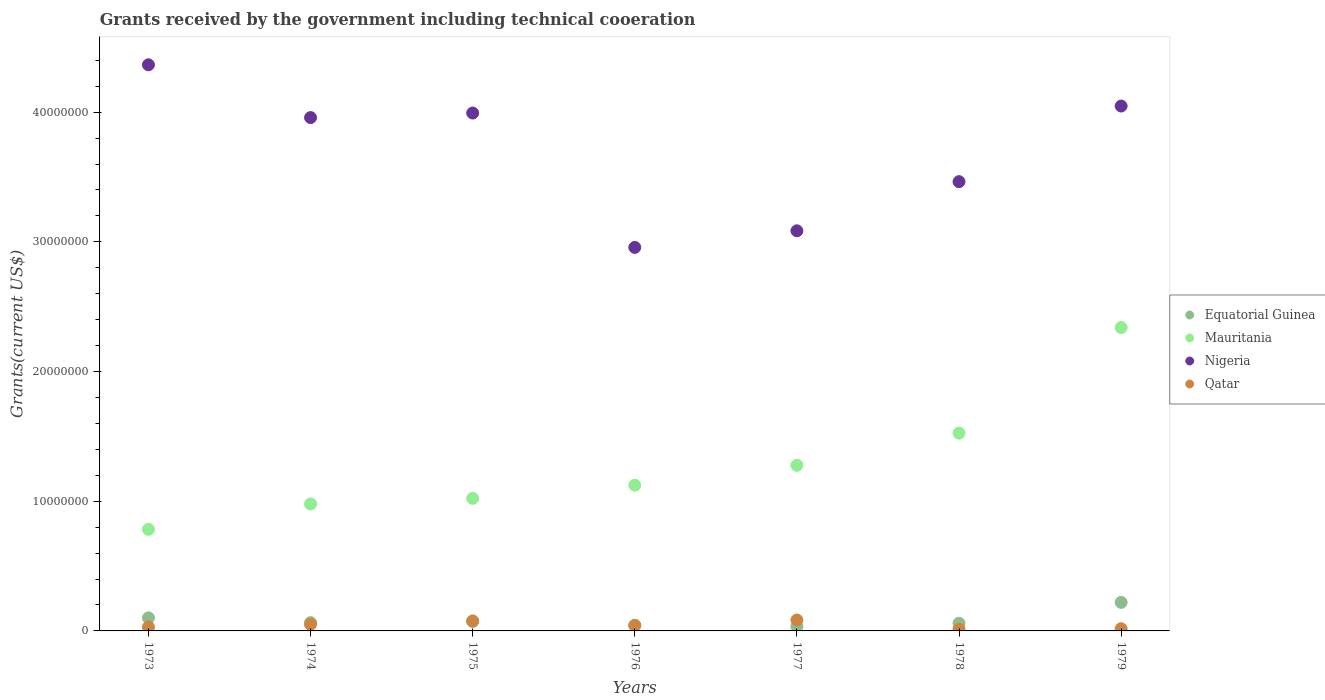How many different coloured dotlines are there?
Ensure brevity in your answer.  4. What is the total grants received by the government in Qatar in 1979?
Your response must be concise. 1.70e+05. Across all years, what is the maximum total grants received by the government in Nigeria?
Keep it short and to the point. 4.36e+07. Across all years, what is the minimum total grants received by the government in Mauritania?
Ensure brevity in your answer.  7.83e+06. In which year was the total grants received by the government in Nigeria maximum?
Your answer should be compact. 1973. What is the total total grants received by the government in Nigeria in the graph?
Make the answer very short. 2.59e+08. What is the difference between the total grants received by the government in Mauritania in 1976 and that in 1979?
Your answer should be compact. -1.22e+07. What is the difference between the total grants received by the government in Qatar in 1979 and the total grants received by the government in Nigeria in 1975?
Your answer should be very brief. -3.98e+07. What is the average total grants received by the government in Equatorial Guinea per year?
Offer a terse response. 8.47e+05. What is the ratio of the total grants received by the government in Equatorial Guinea in 1973 to that in 1979?
Keep it short and to the point. 0.46. Is the difference between the total grants received by the government in Equatorial Guinea in 1974 and 1978 greater than the difference between the total grants received by the government in Qatar in 1974 and 1978?
Your answer should be very brief. No. What is the difference between the highest and the second highest total grants received by the government in Mauritania?
Provide a short and direct response. 8.14e+06. What is the difference between the highest and the lowest total grants received by the government in Qatar?
Offer a very short reply. 7.00e+05. In how many years, is the total grants received by the government in Equatorial Guinea greater than the average total grants received by the government in Equatorial Guinea taken over all years?
Provide a succinct answer. 2. Does the total grants received by the government in Equatorial Guinea monotonically increase over the years?
Ensure brevity in your answer.  No. Is the total grants received by the government in Mauritania strictly greater than the total grants received by the government in Qatar over the years?
Offer a terse response. Yes. Is the total grants received by the government in Nigeria strictly less than the total grants received by the government in Qatar over the years?
Offer a terse response. No. Are the values on the major ticks of Y-axis written in scientific E-notation?
Your response must be concise. No. Where does the legend appear in the graph?
Make the answer very short. Center right. How many legend labels are there?
Provide a succinct answer. 4. What is the title of the graph?
Your answer should be compact. Grants received by the government including technical cooeration. Does "Virgin Islands" appear as one of the legend labels in the graph?
Provide a short and direct response. No. What is the label or title of the Y-axis?
Offer a terse response. Grants(current US$). What is the Grants(current US$) in Equatorial Guinea in 1973?
Provide a short and direct response. 1.01e+06. What is the Grants(current US$) of Mauritania in 1973?
Give a very brief answer. 7.83e+06. What is the Grants(current US$) of Nigeria in 1973?
Make the answer very short. 4.36e+07. What is the Grants(current US$) in Qatar in 1973?
Your response must be concise. 3.00e+05. What is the Grants(current US$) in Equatorial Guinea in 1974?
Offer a terse response. 6.40e+05. What is the Grants(current US$) of Mauritania in 1974?
Provide a succinct answer. 9.79e+06. What is the Grants(current US$) of Nigeria in 1974?
Your response must be concise. 3.96e+07. What is the Grants(current US$) in Qatar in 1974?
Provide a succinct answer. 5.10e+05. What is the Grants(current US$) of Equatorial Guinea in 1975?
Offer a very short reply. 7.30e+05. What is the Grants(current US$) in Mauritania in 1975?
Your response must be concise. 1.02e+07. What is the Grants(current US$) in Nigeria in 1975?
Provide a succinct answer. 3.99e+07. What is the Grants(current US$) of Qatar in 1975?
Ensure brevity in your answer.  7.70e+05. What is the Grants(current US$) of Equatorial Guinea in 1976?
Your answer should be very brief. 4.20e+05. What is the Grants(current US$) of Mauritania in 1976?
Your answer should be compact. 1.12e+07. What is the Grants(current US$) in Nigeria in 1976?
Provide a succinct answer. 2.96e+07. What is the Grants(current US$) of Mauritania in 1977?
Provide a succinct answer. 1.28e+07. What is the Grants(current US$) in Nigeria in 1977?
Provide a short and direct response. 3.08e+07. What is the Grants(current US$) in Qatar in 1977?
Keep it short and to the point. 8.40e+05. What is the Grants(current US$) in Equatorial Guinea in 1978?
Provide a succinct answer. 5.90e+05. What is the Grants(current US$) in Mauritania in 1978?
Provide a succinct answer. 1.52e+07. What is the Grants(current US$) of Nigeria in 1978?
Your answer should be very brief. 3.46e+07. What is the Grants(current US$) in Equatorial Guinea in 1979?
Keep it short and to the point. 2.20e+06. What is the Grants(current US$) of Mauritania in 1979?
Offer a very short reply. 2.34e+07. What is the Grants(current US$) of Nigeria in 1979?
Offer a very short reply. 4.05e+07. What is the Grants(current US$) of Qatar in 1979?
Your answer should be compact. 1.70e+05. Across all years, what is the maximum Grants(current US$) in Equatorial Guinea?
Offer a terse response. 2.20e+06. Across all years, what is the maximum Grants(current US$) in Mauritania?
Keep it short and to the point. 2.34e+07. Across all years, what is the maximum Grants(current US$) in Nigeria?
Offer a very short reply. 4.36e+07. Across all years, what is the maximum Grants(current US$) in Qatar?
Your response must be concise. 8.40e+05. Across all years, what is the minimum Grants(current US$) in Equatorial Guinea?
Your response must be concise. 3.40e+05. Across all years, what is the minimum Grants(current US$) of Mauritania?
Keep it short and to the point. 7.83e+06. Across all years, what is the minimum Grants(current US$) in Nigeria?
Ensure brevity in your answer.  2.96e+07. What is the total Grants(current US$) in Equatorial Guinea in the graph?
Make the answer very short. 5.93e+06. What is the total Grants(current US$) of Mauritania in the graph?
Give a very brief answer. 9.05e+07. What is the total Grants(current US$) in Nigeria in the graph?
Give a very brief answer. 2.59e+08. What is the total Grants(current US$) in Qatar in the graph?
Make the answer very short. 3.16e+06. What is the difference between the Grants(current US$) in Mauritania in 1973 and that in 1974?
Offer a very short reply. -1.96e+06. What is the difference between the Grants(current US$) of Nigeria in 1973 and that in 1974?
Provide a succinct answer. 4.07e+06. What is the difference between the Grants(current US$) in Qatar in 1973 and that in 1974?
Ensure brevity in your answer.  -2.10e+05. What is the difference between the Grants(current US$) in Mauritania in 1973 and that in 1975?
Ensure brevity in your answer.  -2.39e+06. What is the difference between the Grants(current US$) in Nigeria in 1973 and that in 1975?
Offer a terse response. 3.72e+06. What is the difference between the Grants(current US$) of Qatar in 1973 and that in 1975?
Keep it short and to the point. -4.70e+05. What is the difference between the Grants(current US$) of Equatorial Guinea in 1973 and that in 1976?
Your answer should be compact. 5.90e+05. What is the difference between the Grants(current US$) of Mauritania in 1973 and that in 1976?
Your response must be concise. -3.41e+06. What is the difference between the Grants(current US$) of Nigeria in 1973 and that in 1976?
Your answer should be very brief. 1.41e+07. What is the difference between the Grants(current US$) of Equatorial Guinea in 1973 and that in 1977?
Make the answer very short. 6.70e+05. What is the difference between the Grants(current US$) in Mauritania in 1973 and that in 1977?
Your response must be concise. -4.94e+06. What is the difference between the Grants(current US$) of Nigeria in 1973 and that in 1977?
Provide a succinct answer. 1.28e+07. What is the difference between the Grants(current US$) in Qatar in 1973 and that in 1977?
Provide a succinct answer. -5.40e+05. What is the difference between the Grants(current US$) of Equatorial Guinea in 1973 and that in 1978?
Provide a succinct answer. 4.20e+05. What is the difference between the Grants(current US$) in Mauritania in 1973 and that in 1978?
Keep it short and to the point. -7.42e+06. What is the difference between the Grants(current US$) of Nigeria in 1973 and that in 1978?
Provide a short and direct response. 9.01e+06. What is the difference between the Grants(current US$) in Equatorial Guinea in 1973 and that in 1979?
Provide a succinct answer. -1.19e+06. What is the difference between the Grants(current US$) of Mauritania in 1973 and that in 1979?
Give a very brief answer. -1.56e+07. What is the difference between the Grants(current US$) in Nigeria in 1973 and that in 1979?
Offer a terse response. 3.18e+06. What is the difference between the Grants(current US$) of Mauritania in 1974 and that in 1975?
Provide a succinct answer. -4.30e+05. What is the difference between the Grants(current US$) in Nigeria in 1974 and that in 1975?
Your answer should be very brief. -3.50e+05. What is the difference between the Grants(current US$) in Equatorial Guinea in 1974 and that in 1976?
Keep it short and to the point. 2.20e+05. What is the difference between the Grants(current US$) of Mauritania in 1974 and that in 1976?
Keep it short and to the point. -1.45e+06. What is the difference between the Grants(current US$) in Nigeria in 1974 and that in 1976?
Keep it short and to the point. 1.00e+07. What is the difference between the Grants(current US$) in Qatar in 1974 and that in 1976?
Provide a succinct answer. 8.00e+04. What is the difference between the Grants(current US$) of Equatorial Guinea in 1974 and that in 1977?
Offer a terse response. 3.00e+05. What is the difference between the Grants(current US$) of Mauritania in 1974 and that in 1977?
Offer a terse response. -2.98e+06. What is the difference between the Grants(current US$) of Nigeria in 1974 and that in 1977?
Your answer should be very brief. 8.73e+06. What is the difference between the Grants(current US$) of Qatar in 1974 and that in 1977?
Your response must be concise. -3.30e+05. What is the difference between the Grants(current US$) in Equatorial Guinea in 1974 and that in 1978?
Ensure brevity in your answer.  5.00e+04. What is the difference between the Grants(current US$) in Mauritania in 1974 and that in 1978?
Your answer should be very brief. -5.46e+06. What is the difference between the Grants(current US$) in Nigeria in 1974 and that in 1978?
Your answer should be very brief. 4.94e+06. What is the difference between the Grants(current US$) of Equatorial Guinea in 1974 and that in 1979?
Ensure brevity in your answer.  -1.56e+06. What is the difference between the Grants(current US$) of Mauritania in 1974 and that in 1979?
Offer a terse response. -1.36e+07. What is the difference between the Grants(current US$) of Nigeria in 1974 and that in 1979?
Offer a very short reply. -8.90e+05. What is the difference between the Grants(current US$) in Qatar in 1974 and that in 1979?
Make the answer very short. 3.40e+05. What is the difference between the Grants(current US$) in Mauritania in 1975 and that in 1976?
Provide a short and direct response. -1.02e+06. What is the difference between the Grants(current US$) in Nigeria in 1975 and that in 1976?
Provide a succinct answer. 1.04e+07. What is the difference between the Grants(current US$) of Qatar in 1975 and that in 1976?
Provide a succinct answer. 3.40e+05. What is the difference between the Grants(current US$) in Mauritania in 1975 and that in 1977?
Make the answer very short. -2.55e+06. What is the difference between the Grants(current US$) in Nigeria in 1975 and that in 1977?
Make the answer very short. 9.08e+06. What is the difference between the Grants(current US$) of Mauritania in 1975 and that in 1978?
Your answer should be compact. -5.03e+06. What is the difference between the Grants(current US$) of Nigeria in 1975 and that in 1978?
Offer a very short reply. 5.29e+06. What is the difference between the Grants(current US$) in Qatar in 1975 and that in 1978?
Ensure brevity in your answer.  6.30e+05. What is the difference between the Grants(current US$) of Equatorial Guinea in 1975 and that in 1979?
Keep it short and to the point. -1.47e+06. What is the difference between the Grants(current US$) of Mauritania in 1975 and that in 1979?
Keep it short and to the point. -1.32e+07. What is the difference between the Grants(current US$) in Nigeria in 1975 and that in 1979?
Provide a short and direct response. -5.40e+05. What is the difference between the Grants(current US$) of Qatar in 1975 and that in 1979?
Your answer should be compact. 6.00e+05. What is the difference between the Grants(current US$) of Mauritania in 1976 and that in 1977?
Your answer should be very brief. -1.53e+06. What is the difference between the Grants(current US$) in Nigeria in 1976 and that in 1977?
Ensure brevity in your answer.  -1.28e+06. What is the difference between the Grants(current US$) in Qatar in 1976 and that in 1977?
Offer a terse response. -4.10e+05. What is the difference between the Grants(current US$) in Equatorial Guinea in 1976 and that in 1978?
Give a very brief answer. -1.70e+05. What is the difference between the Grants(current US$) in Mauritania in 1976 and that in 1978?
Offer a terse response. -4.01e+06. What is the difference between the Grants(current US$) in Nigeria in 1976 and that in 1978?
Give a very brief answer. -5.07e+06. What is the difference between the Grants(current US$) of Qatar in 1976 and that in 1978?
Keep it short and to the point. 2.90e+05. What is the difference between the Grants(current US$) of Equatorial Guinea in 1976 and that in 1979?
Offer a very short reply. -1.78e+06. What is the difference between the Grants(current US$) of Mauritania in 1976 and that in 1979?
Your answer should be compact. -1.22e+07. What is the difference between the Grants(current US$) in Nigeria in 1976 and that in 1979?
Your response must be concise. -1.09e+07. What is the difference between the Grants(current US$) of Qatar in 1976 and that in 1979?
Keep it short and to the point. 2.60e+05. What is the difference between the Grants(current US$) of Mauritania in 1977 and that in 1978?
Ensure brevity in your answer.  -2.48e+06. What is the difference between the Grants(current US$) in Nigeria in 1977 and that in 1978?
Give a very brief answer. -3.79e+06. What is the difference between the Grants(current US$) of Qatar in 1977 and that in 1978?
Your response must be concise. 7.00e+05. What is the difference between the Grants(current US$) of Equatorial Guinea in 1977 and that in 1979?
Your answer should be very brief. -1.86e+06. What is the difference between the Grants(current US$) of Mauritania in 1977 and that in 1979?
Make the answer very short. -1.06e+07. What is the difference between the Grants(current US$) in Nigeria in 1977 and that in 1979?
Provide a succinct answer. -9.62e+06. What is the difference between the Grants(current US$) in Qatar in 1977 and that in 1979?
Your answer should be compact. 6.70e+05. What is the difference between the Grants(current US$) of Equatorial Guinea in 1978 and that in 1979?
Your response must be concise. -1.61e+06. What is the difference between the Grants(current US$) in Mauritania in 1978 and that in 1979?
Make the answer very short. -8.14e+06. What is the difference between the Grants(current US$) of Nigeria in 1978 and that in 1979?
Ensure brevity in your answer.  -5.83e+06. What is the difference between the Grants(current US$) in Equatorial Guinea in 1973 and the Grants(current US$) in Mauritania in 1974?
Provide a succinct answer. -8.78e+06. What is the difference between the Grants(current US$) of Equatorial Guinea in 1973 and the Grants(current US$) of Nigeria in 1974?
Offer a terse response. -3.86e+07. What is the difference between the Grants(current US$) in Mauritania in 1973 and the Grants(current US$) in Nigeria in 1974?
Ensure brevity in your answer.  -3.18e+07. What is the difference between the Grants(current US$) of Mauritania in 1973 and the Grants(current US$) of Qatar in 1974?
Offer a very short reply. 7.32e+06. What is the difference between the Grants(current US$) in Nigeria in 1973 and the Grants(current US$) in Qatar in 1974?
Your answer should be compact. 4.31e+07. What is the difference between the Grants(current US$) in Equatorial Guinea in 1973 and the Grants(current US$) in Mauritania in 1975?
Your answer should be compact. -9.21e+06. What is the difference between the Grants(current US$) of Equatorial Guinea in 1973 and the Grants(current US$) of Nigeria in 1975?
Ensure brevity in your answer.  -3.89e+07. What is the difference between the Grants(current US$) in Mauritania in 1973 and the Grants(current US$) in Nigeria in 1975?
Provide a succinct answer. -3.21e+07. What is the difference between the Grants(current US$) of Mauritania in 1973 and the Grants(current US$) of Qatar in 1975?
Offer a terse response. 7.06e+06. What is the difference between the Grants(current US$) in Nigeria in 1973 and the Grants(current US$) in Qatar in 1975?
Ensure brevity in your answer.  4.29e+07. What is the difference between the Grants(current US$) of Equatorial Guinea in 1973 and the Grants(current US$) of Mauritania in 1976?
Keep it short and to the point. -1.02e+07. What is the difference between the Grants(current US$) in Equatorial Guinea in 1973 and the Grants(current US$) in Nigeria in 1976?
Make the answer very short. -2.86e+07. What is the difference between the Grants(current US$) in Equatorial Guinea in 1973 and the Grants(current US$) in Qatar in 1976?
Keep it short and to the point. 5.80e+05. What is the difference between the Grants(current US$) in Mauritania in 1973 and the Grants(current US$) in Nigeria in 1976?
Offer a terse response. -2.17e+07. What is the difference between the Grants(current US$) in Mauritania in 1973 and the Grants(current US$) in Qatar in 1976?
Provide a short and direct response. 7.40e+06. What is the difference between the Grants(current US$) in Nigeria in 1973 and the Grants(current US$) in Qatar in 1976?
Make the answer very short. 4.32e+07. What is the difference between the Grants(current US$) in Equatorial Guinea in 1973 and the Grants(current US$) in Mauritania in 1977?
Keep it short and to the point. -1.18e+07. What is the difference between the Grants(current US$) of Equatorial Guinea in 1973 and the Grants(current US$) of Nigeria in 1977?
Your answer should be very brief. -2.98e+07. What is the difference between the Grants(current US$) of Equatorial Guinea in 1973 and the Grants(current US$) of Qatar in 1977?
Offer a very short reply. 1.70e+05. What is the difference between the Grants(current US$) in Mauritania in 1973 and the Grants(current US$) in Nigeria in 1977?
Offer a very short reply. -2.30e+07. What is the difference between the Grants(current US$) in Mauritania in 1973 and the Grants(current US$) in Qatar in 1977?
Ensure brevity in your answer.  6.99e+06. What is the difference between the Grants(current US$) in Nigeria in 1973 and the Grants(current US$) in Qatar in 1977?
Offer a terse response. 4.28e+07. What is the difference between the Grants(current US$) of Equatorial Guinea in 1973 and the Grants(current US$) of Mauritania in 1978?
Offer a very short reply. -1.42e+07. What is the difference between the Grants(current US$) in Equatorial Guinea in 1973 and the Grants(current US$) in Nigeria in 1978?
Offer a terse response. -3.36e+07. What is the difference between the Grants(current US$) of Equatorial Guinea in 1973 and the Grants(current US$) of Qatar in 1978?
Make the answer very short. 8.70e+05. What is the difference between the Grants(current US$) in Mauritania in 1973 and the Grants(current US$) in Nigeria in 1978?
Offer a very short reply. -2.68e+07. What is the difference between the Grants(current US$) of Mauritania in 1973 and the Grants(current US$) of Qatar in 1978?
Your response must be concise. 7.69e+06. What is the difference between the Grants(current US$) of Nigeria in 1973 and the Grants(current US$) of Qatar in 1978?
Offer a terse response. 4.35e+07. What is the difference between the Grants(current US$) in Equatorial Guinea in 1973 and the Grants(current US$) in Mauritania in 1979?
Your answer should be compact. -2.24e+07. What is the difference between the Grants(current US$) in Equatorial Guinea in 1973 and the Grants(current US$) in Nigeria in 1979?
Make the answer very short. -3.95e+07. What is the difference between the Grants(current US$) of Equatorial Guinea in 1973 and the Grants(current US$) of Qatar in 1979?
Your answer should be very brief. 8.40e+05. What is the difference between the Grants(current US$) of Mauritania in 1973 and the Grants(current US$) of Nigeria in 1979?
Provide a short and direct response. -3.26e+07. What is the difference between the Grants(current US$) of Mauritania in 1973 and the Grants(current US$) of Qatar in 1979?
Keep it short and to the point. 7.66e+06. What is the difference between the Grants(current US$) in Nigeria in 1973 and the Grants(current US$) in Qatar in 1979?
Ensure brevity in your answer.  4.35e+07. What is the difference between the Grants(current US$) in Equatorial Guinea in 1974 and the Grants(current US$) in Mauritania in 1975?
Give a very brief answer. -9.58e+06. What is the difference between the Grants(current US$) of Equatorial Guinea in 1974 and the Grants(current US$) of Nigeria in 1975?
Keep it short and to the point. -3.93e+07. What is the difference between the Grants(current US$) in Equatorial Guinea in 1974 and the Grants(current US$) in Qatar in 1975?
Your response must be concise. -1.30e+05. What is the difference between the Grants(current US$) of Mauritania in 1974 and the Grants(current US$) of Nigeria in 1975?
Give a very brief answer. -3.01e+07. What is the difference between the Grants(current US$) of Mauritania in 1974 and the Grants(current US$) of Qatar in 1975?
Provide a succinct answer. 9.02e+06. What is the difference between the Grants(current US$) of Nigeria in 1974 and the Grants(current US$) of Qatar in 1975?
Your answer should be very brief. 3.88e+07. What is the difference between the Grants(current US$) in Equatorial Guinea in 1974 and the Grants(current US$) in Mauritania in 1976?
Offer a very short reply. -1.06e+07. What is the difference between the Grants(current US$) of Equatorial Guinea in 1974 and the Grants(current US$) of Nigeria in 1976?
Make the answer very short. -2.89e+07. What is the difference between the Grants(current US$) of Mauritania in 1974 and the Grants(current US$) of Nigeria in 1976?
Provide a short and direct response. -1.98e+07. What is the difference between the Grants(current US$) in Mauritania in 1974 and the Grants(current US$) in Qatar in 1976?
Your response must be concise. 9.36e+06. What is the difference between the Grants(current US$) of Nigeria in 1974 and the Grants(current US$) of Qatar in 1976?
Your answer should be compact. 3.92e+07. What is the difference between the Grants(current US$) in Equatorial Guinea in 1974 and the Grants(current US$) in Mauritania in 1977?
Make the answer very short. -1.21e+07. What is the difference between the Grants(current US$) of Equatorial Guinea in 1974 and the Grants(current US$) of Nigeria in 1977?
Keep it short and to the point. -3.02e+07. What is the difference between the Grants(current US$) of Equatorial Guinea in 1974 and the Grants(current US$) of Qatar in 1977?
Offer a terse response. -2.00e+05. What is the difference between the Grants(current US$) in Mauritania in 1974 and the Grants(current US$) in Nigeria in 1977?
Give a very brief answer. -2.11e+07. What is the difference between the Grants(current US$) of Mauritania in 1974 and the Grants(current US$) of Qatar in 1977?
Ensure brevity in your answer.  8.95e+06. What is the difference between the Grants(current US$) in Nigeria in 1974 and the Grants(current US$) in Qatar in 1977?
Your answer should be very brief. 3.87e+07. What is the difference between the Grants(current US$) in Equatorial Guinea in 1974 and the Grants(current US$) in Mauritania in 1978?
Offer a very short reply. -1.46e+07. What is the difference between the Grants(current US$) in Equatorial Guinea in 1974 and the Grants(current US$) in Nigeria in 1978?
Offer a terse response. -3.40e+07. What is the difference between the Grants(current US$) in Mauritania in 1974 and the Grants(current US$) in Nigeria in 1978?
Your answer should be very brief. -2.48e+07. What is the difference between the Grants(current US$) in Mauritania in 1974 and the Grants(current US$) in Qatar in 1978?
Make the answer very short. 9.65e+06. What is the difference between the Grants(current US$) of Nigeria in 1974 and the Grants(current US$) of Qatar in 1978?
Your answer should be very brief. 3.94e+07. What is the difference between the Grants(current US$) in Equatorial Guinea in 1974 and the Grants(current US$) in Mauritania in 1979?
Your answer should be compact. -2.28e+07. What is the difference between the Grants(current US$) of Equatorial Guinea in 1974 and the Grants(current US$) of Nigeria in 1979?
Keep it short and to the point. -3.98e+07. What is the difference between the Grants(current US$) of Mauritania in 1974 and the Grants(current US$) of Nigeria in 1979?
Give a very brief answer. -3.07e+07. What is the difference between the Grants(current US$) in Mauritania in 1974 and the Grants(current US$) in Qatar in 1979?
Provide a short and direct response. 9.62e+06. What is the difference between the Grants(current US$) in Nigeria in 1974 and the Grants(current US$) in Qatar in 1979?
Provide a short and direct response. 3.94e+07. What is the difference between the Grants(current US$) of Equatorial Guinea in 1975 and the Grants(current US$) of Mauritania in 1976?
Ensure brevity in your answer.  -1.05e+07. What is the difference between the Grants(current US$) in Equatorial Guinea in 1975 and the Grants(current US$) in Nigeria in 1976?
Give a very brief answer. -2.88e+07. What is the difference between the Grants(current US$) in Equatorial Guinea in 1975 and the Grants(current US$) in Qatar in 1976?
Your answer should be very brief. 3.00e+05. What is the difference between the Grants(current US$) of Mauritania in 1975 and the Grants(current US$) of Nigeria in 1976?
Provide a short and direct response. -1.94e+07. What is the difference between the Grants(current US$) of Mauritania in 1975 and the Grants(current US$) of Qatar in 1976?
Your answer should be very brief. 9.79e+06. What is the difference between the Grants(current US$) in Nigeria in 1975 and the Grants(current US$) in Qatar in 1976?
Offer a very short reply. 3.95e+07. What is the difference between the Grants(current US$) of Equatorial Guinea in 1975 and the Grants(current US$) of Mauritania in 1977?
Offer a terse response. -1.20e+07. What is the difference between the Grants(current US$) of Equatorial Guinea in 1975 and the Grants(current US$) of Nigeria in 1977?
Provide a succinct answer. -3.01e+07. What is the difference between the Grants(current US$) of Mauritania in 1975 and the Grants(current US$) of Nigeria in 1977?
Make the answer very short. -2.06e+07. What is the difference between the Grants(current US$) of Mauritania in 1975 and the Grants(current US$) of Qatar in 1977?
Provide a succinct answer. 9.38e+06. What is the difference between the Grants(current US$) in Nigeria in 1975 and the Grants(current US$) in Qatar in 1977?
Offer a terse response. 3.91e+07. What is the difference between the Grants(current US$) of Equatorial Guinea in 1975 and the Grants(current US$) of Mauritania in 1978?
Ensure brevity in your answer.  -1.45e+07. What is the difference between the Grants(current US$) of Equatorial Guinea in 1975 and the Grants(current US$) of Nigeria in 1978?
Provide a succinct answer. -3.39e+07. What is the difference between the Grants(current US$) in Equatorial Guinea in 1975 and the Grants(current US$) in Qatar in 1978?
Keep it short and to the point. 5.90e+05. What is the difference between the Grants(current US$) of Mauritania in 1975 and the Grants(current US$) of Nigeria in 1978?
Provide a succinct answer. -2.44e+07. What is the difference between the Grants(current US$) in Mauritania in 1975 and the Grants(current US$) in Qatar in 1978?
Your response must be concise. 1.01e+07. What is the difference between the Grants(current US$) of Nigeria in 1975 and the Grants(current US$) of Qatar in 1978?
Offer a terse response. 3.98e+07. What is the difference between the Grants(current US$) of Equatorial Guinea in 1975 and the Grants(current US$) of Mauritania in 1979?
Your answer should be compact. -2.27e+07. What is the difference between the Grants(current US$) in Equatorial Guinea in 1975 and the Grants(current US$) in Nigeria in 1979?
Ensure brevity in your answer.  -3.97e+07. What is the difference between the Grants(current US$) in Equatorial Guinea in 1975 and the Grants(current US$) in Qatar in 1979?
Keep it short and to the point. 5.60e+05. What is the difference between the Grants(current US$) in Mauritania in 1975 and the Grants(current US$) in Nigeria in 1979?
Offer a very short reply. -3.02e+07. What is the difference between the Grants(current US$) of Mauritania in 1975 and the Grants(current US$) of Qatar in 1979?
Your answer should be compact. 1.00e+07. What is the difference between the Grants(current US$) in Nigeria in 1975 and the Grants(current US$) in Qatar in 1979?
Offer a very short reply. 3.98e+07. What is the difference between the Grants(current US$) of Equatorial Guinea in 1976 and the Grants(current US$) of Mauritania in 1977?
Ensure brevity in your answer.  -1.24e+07. What is the difference between the Grants(current US$) of Equatorial Guinea in 1976 and the Grants(current US$) of Nigeria in 1977?
Ensure brevity in your answer.  -3.04e+07. What is the difference between the Grants(current US$) of Equatorial Guinea in 1976 and the Grants(current US$) of Qatar in 1977?
Your response must be concise. -4.20e+05. What is the difference between the Grants(current US$) of Mauritania in 1976 and the Grants(current US$) of Nigeria in 1977?
Offer a terse response. -1.96e+07. What is the difference between the Grants(current US$) of Mauritania in 1976 and the Grants(current US$) of Qatar in 1977?
Ensure brevity in your answer.  1.04e+07. What is the difference between the Grants(current US$) of Nigeria in 1976 and the Grants(current US$) of Qatar in 1977?
Offer a terse response. 2.87e+07. What is the difference between the Grants(current US$) of Equatorial Guinea in 1976 and the Grants(current US$) of Mauritania in 1978?
Offer a very short reply. -1.48e+07. What is the difference between the Grants(current US$) of Equatorial Guinea in 1976 and the Grants(current US$) of Nigeria in 1978?
Ensure brevity in your answer.  -3.42e+07. What is the difference between the Grants(current US$) in Equatorial Guinea in 1976 and the Grants(current US$) in Qatar in 1978?
Give a very brief answer. 2.80e+05. What is the difference between the Grants(current US$) of Mauritania in 1976 and the Grants(current US$) of Nigeria in 1978?
Offer a very short reply. -2.34e+07. What is the difference between the Grants(current US$) in Mauritania in 1976 and the Grants(current US$) in Qatar in 1978?
Give a very brief answer. 1.11e+07. What is the difference between the Grants(current US$) of Nigeria in 1976 and the Grants(current US$) of Qatar in 1978?
Provide a short and direct response. 2.94e+07. What is the difference between the Grants(current US$) in Equatorial Guinea in 1976 and the Grants(current US$) in Mauritania in 1979?
Your answer should be compact. -2.30e+07. What is the difference between the Grants(current US$) in Equatorial Guinea in 1976 and the Grants(current US$) in Nigeria in 1979?
Offer a very short reply. -4.00e+07. What is the difference between the Grants(current US$) in Equatorial Guinea in 1976 and the Grants(current US$) in Qatar in 1979?
Offer a very short reply. 2.50e+05. What is the difference between the Grants(current US$) of Mauritania in 1976 and the Grants(current US$) of Nigeria in 1979?
Offer a terse response. -2.92e+07. What is the difference between the Grants(current US$) in Mauritania in 1976 and the Grants(current US$) in Qatar in 1979?
Make the answer very short. 1.11e+07. What is the difference between the Grants(current US$) in Nigeria in 1976 and the Grants(current US$) in Qatar in 1979?
Provide a short and direct response. 2.94e+07. What is the difference between the Grants(current US$) in Equatorial Guinea in 1977 and the Grants(current US$) in Mauritania in 1978?
Provide a succinct answer. -1.49e+07. What is the difference between the Grants(current US$) in Equatorial Guinea in 1977 and the Grants(current US$) in Nigeria in 1978?
Your answer should be compact. -3.43e+07. What is the difference between the Grants(current US$) in Equatorial Guinea in 1977 and the Grants(current US$) in Qatar in 1978?
Provide a short and direct response. 2.00e+05. What is the difference between the Grants(current US$) in Mauritania in 1977 and the Grants(current US$) in Nigeria in 1978?
Provide a succinct answer. -2.19e+07. What is the difference between the Grants(current US$) of Mauritania in 1977 and the Grants(current US$) of Qatar in 1978?
Keep it short and to the point. 1.26e+07. What is the difference between the Grants(current US$) of Nigeria in 1977 and the Grants(current US$) of Qatar in 1978?
Keep it short and to the point. 3.07e+07. What is the difference between the Grants(current US$) of Equatorial Guinea in 1977 and the Grants(current US$) of Mauritania in 1979?
Give a very brief answer. -2.30e+07. What is the difference between the Grants(current US$) in Equatorial Guinea in 1977 and the Grants(current US$) in Nigeria in 1979?
Your response must be concise. -4.01e+07. What is the difference between the Grants(current US$) in Equatorial Guinea in 1977 and the Grants(current US$) in Qatar in 1979?
Offer a very short reply. 1.70e+05. What is the difference between the Grants(current US$) in Mauritania in 1977 and the Grants(current US$) in Nigeria in 1979?
Provide a short and direct response. -2.77e+07. What is the difference between the Grants(current US$) of Mauritania in 1977 and the Grants(current US$) of Qatar in 1979?
Your answer should be compact. 1.26e+07. What is the difference between the Grants(current US$) of Nigeria in 1977 and the Grants(current US$) of Qatar in 1979?
Your answer should be compact. 3.07e+07. What is the difference between the Grants(current US$) of Equatorial Guinea in 1978 and the Grants(current US$) of Mauritania in 1979?
Offer a very short reply. -2.28e+07. What is the difference between the Grants(current US$) in Equatorial Guinea in 1978 and the Grants(current US$) in Nigeria in 1979?
Offer a very short reply. -3.99e+07. What is the difference between the Grants(current US$) of Mauritania in 1978 and the Grants(current US$) of Nigeria in 1979?
Offer a terse response. -2.52e+07. What is the difference between the Grants(current US$) of Mauritania in 1978 and the Grants(current US$) of Qatar in 1979?
Offer a very short reply. 1.51e+07. What is the difference between the Grants(current US$) in Nigeria in 1978 and the Grants(current US$) in Qatar in 1979?
Provide a succinct answer. 3.45e+07. What is the average Grants(current US$) of Equatorial Guinea per year?
Your answer should be compact. 8.47e+05. What is the average Grants(current US$) in Mauritania per year?
Ensure brevity in your answer.  1.29e+07. What is the average Grants(current US$) of Nigeria per year?
Give a very brief answer. 3.70e+07. What is the average Grants(current US$) in Qatar per year?
Your answer should be compact. 4.51e+05. In the year 1973, what is the difference between the Grants(current US$) in Equatorial Guinea and Grants(current US$) in Mauritania?
Provide a short and direct response. -6.82e+06. In the year 1973, what is the difference between the Grants(current US$) of Equatorial Guinea and Grants(current US$) of Nigeria?
Ensure brevity in your answer.  -4.26e+07. In the year 1973, what is the difference between the Grants(current US$) in Equatorial Guinea and Grants(current US$) in Qatar?
Your answer should be compact. 7.10e+05. In the year 1973, what is the difference between the Grants(current US$) in Mauritania and Grants(current US$) in Nigeria?
Offer a very short reply. -3.58e+07. In the year 1973, what is the difference between the Grants(current US$) of Mauritania and Grants(current US$) of Qatar?
Your answer should be compact. 7.53e+06. In the year 1973, what is the difference between the Grants(current US$) in Nigeria and Grants(current US$) in Qatar?
Offer a very short reply. 4.34e+07. In the year 1974, what is the difference between the Grants(current US$) of Equatorial Guinea and Grants(current US$) of Mauritania?
Make the answer very short. -9.15e+06. In the year 1974, what is the difference between the Grants(current US$) of Equatorial Guinea and Grants(current US$) of Nigeria?
Your answer should be compact. -3.89e+07. In the year 1974, what is the difference between the Grants(current US$) of Equatorial Guinea and Grants(current US$) of Qatar?
Your answer should be very brief. 1.30e+05. In the year 1974, what is the difference between the Grants(current US$) in Mauritania and Grants(current US$) in Nigeria?
Make the answer very short. -2.98e+07. In the year 1974, what is the difference between the Grants(current US$) of Mauritania and Grants(current US$) of Qatar?
Provide a succinct answer. 9.28e+06. In the year 1974, what is the difference between the Grants(current US$) of Nigeria and Grants(current US$) of Qatar?
Offer a terse response. 3.91e+07. In the year 1975, what is the difference between the Grants(current US$) of Equatorial Guinea and Grants(current US$) of Mauritania?
Your answer should be compact. -9.49e+06. In the year 1975, what is the difference between the Grants(current US$) of Equatorial Guinea and Grants(current US$) of Nigeria?
Provide a succinct answer. -3.92e+07. In the year 1975, what is the difference between the Grants(current US$) in Mauritania and Grants(current US$) in Nigeria?
Provide a succinct answer. -2.97e+07. In the year 1975, what is the difference between the Grants(current US$) in Mauritania and Grants(current US$) in Qatar?
Provide a succinct answer. 9.45e+06. In the year 1975, what is the difference between the Grants(current US$) in Nigeria and Grants(current US$) in Qatar?
Your answer should be very brief. 3.92e+07. In the year 1976, what is the difference between the Grants(current US$) in Equatorial Guinea and Grants(current US$) in Mauritania?
Offer a terse response. -1.08e+07. In the year 1976, what is the difference between the Grants(current US$) in Equatorial Guinea and Grants(current US$) in Nigeria?
Your response must be concise. -2.92e+07. In the year 1976, what is the difference between the Grants(current US$) of Equatorial Guinea and Grants(current US$) of Qatar?
Keep it short and to the point. -10000. In the year 1976, what is the difference between the Grants(current US$) in Mauritania and Grants(current US$) in Nigeria?
Provide a short and direct response. -1.83e+07. In the year 1976, what is the difference between the Grants(current US$) in Mauritania and Grants(current US$) in Qatar?
Provide a succinct answer. 1.08e+07. In the year 1976, what is the difference between the Grants(current US$) of Nigeria and Grants(current US$) of Qatar?
Keep it short and to the point. 2.91e+07. In the year 1977, what is the difference between the Grants(current US$) in Equatorial Guinea and Grants(current US$) in Mauritania?
Keep it short and to the point. -1.24e+07. In the year 1977, what is the difference between the Grants(current US$) of Equatorial Guinea and Grants(current US$) of Nigeria?
Keep it short and to the point. -3.05e+07. In the year 1977, what is the difference between the Grants(current US$) in Equatorial Guinea and Grants(current US$) in Qatar?
Ensure brevity in your answer.  -5.00e+05. In the year 1977, what is the difference between the Grants(current US$) in Mauritania and Grants(current US$) in Nigeria?
Ensure brevity in your answer.  -1.81e+07. In the year 1977, what is the difference between the Grants(current US$) in Mauritania and Grants(current US$) in Qatar?
Make the answer very short. 1.19e+07. In the year 1977, what is the difference between the Grants(current US$) in Nigeria and Grants(current US$) in Qatar?
Give a very brief answer. 3.00e+07. In the year 1978, what is the difference between the Grants(current US$) in Equatorial Guinea and Grants(current US$) in Mauritania?
Provide a succinct answer. -1.47e+07. In the year 1978, what is the difference between the Grants(current US$) of Equatorial Guinea and Grants(current US$) of Nigeria?
Provide a succinct answer. -3.40e+07. In the year 1978, what is the difference between the Grants(current US$) in Mauritania and Grants(current US$) in Nigeria?
Make the answer very short. -1.94e+07. In the year 1978, what is the difference between the Grants(current US$) in Mauritania and Grants(current US$) in Qatar?
Your answer should be compact. 1.51e+07. In the year 1978, what is the difference between the Grants(current US$) of Nigeria and Grants(current US$) of Qatar?
Provide a short and direct response. 3.45e+07. In the year 1979, what is the difference between the Grants(current US$) in Equatorial Guinea and Grants(current US$) in Mauritania?
Ensure brevity in your answer.  -2.12e+07. In the year 1979, what is the difference between the Grants(current US$) in Equatorial Guinea and Grants(current US$) in Nigeria?
Provide a succinct answer. -3.83e+07. In the year 1979, what is the difference between the Grants(current US$) in Equatorial Guinea and Grants(current US$) in Qatar?
Keep it short and to the point. 2.03e+06. In the year 1979, what is the difference between the Grants(current US$) of Mauritania and Grants(current US$) of Nigeria?
Make the answer very short. -1.71e+07. In the year 1979, what is the difference between the Grants(current US$) in Mauritania and Grants(current US$) in Qatar?
Give a very brief answer. 2.32e+07. In the year 1979, what is the difference between the Grants(current US$) in Nigeria and Grants(current US$) in Qatar?
Ensure brevity in your answer.  4.03e+07. What is the ratio of the Grants(current US$) of Equatorial Guinea in 1973 to that in 1974?
Your response must be concise. 1.58. What is the ratio of the Grants(current US$) of Mauritania in 1973 to that in 1974?
Ensure brevity in your answer.  0.8. What is the ratio of the Grants(current US$) in Nigeria in 1973 to that in 1974?
Make the answer very short. 1.1. What is the ratio of the Grants(current US$) in Qatar in 1973 to that in 1974?
Offer a very short reply. 0.59. What is the ratio of the Grants(current US$) in Equatorial Guinea in 1973 to that in 1975?
Offer a terse response. 1.38. What is the ratio of the Grants(current US$) in Mauritania in 1973 to that in 1975?
Your response must be concise. 0.77. What is the ratio of the Grants(current US$) in Nigeria in 1973 to that in 1975?
Offer a very short reply. 1.09. What is the ratio of the Grants(current US$) in Qatar in 1973 to that in 1975?
Offer a very short reply. 0.39. What is the ratio of the Grants(current US$) of Equatorial Guinea in 1973 to that in 1976?
Give a very brief answer. 2.4. What is the ratio of the Grants(current US$) in Mauritania in 1973 to that in 1976?
Give a very brief answer. 0.7. What is the ratio of the Grants(current US$) in Nigeria in 1973 to that in 1976?
Keep it short and to the point. 1.48. What is the ratio of the Grants(current US$) in Qatar in 1973 to that in 1976?
Offer a terse response. 0.7. What is the ratio of the Grants(current US$) of Equatorial Guinea in 1973 to that in 1977?
Make the answer very short. 2.97. What is the ratio of the Grants(current US$) of Mauritania in 1973 to that in 1977?
Offer a very short reply. 0.61. What is the ratio of the Grants(current US$) in Nigeria in 1973 to that in 1977?
Offer a very short reply. 1.41. What is the ratio of the Grants(current US$) of Qatar in 1973 to that in 1977?
Ensure brevity in your answer.  0.36. What is the ratio of the Grants(current US$) of Equatorial Guinea in 1973 to that in 1978?
Offer a terse response. 1.71. What is the ratio of the Grants(current US$) in Mauritania in 1973 to that in 1978?
Offer a very short reply. 0.51. What is the ratio of the Grants(current US$) of Nigeria in 1973 to that in 1978?
Provide a succinct answer. 1.26. What is the ratio of the Grants(current US$) in Qatar in 1973 to that in 1978?
Your answer should be very brief. 2.14. What is the ratio of the Grants(current US$) in Equatorial Guinea in 1973 to that in 1979?
Your answer should be compact. 0.46. What is the ratio of the Grants(current US$) of Mauritania in 1973 to that in 1979?
Ensure brevity in your answer.  0.33. What is the ratio of the Grants(current US$) in Nigeria in 1973 to that in 1979?
Your answer should be compact. 1.08. What is the ratio of the Grants(current US$) in Qatar in 1973 to that in 1979?
Your response must be concise. 1.76. What is the ratio of the Grants(current US$) of Equatorial Guinea in 1974 to that in 1975?
Keep it short and to the point. 0.88. What is the ratio of the Grants(current US$) in Mauritania in 1974 to that in 1975?
Make the answer very short. 0.96. What is the ratio of the Grants(current US$) in Qatar in 1974 to that in 1975?
Your answer should be compact. 0.66. What is the ratio of the Grants(current US$) in Equatorial Guinea in 1974 to that in 1976?
Ensure brevity in your answer.  1.52. What is the ratio of the Grants(current US$) of Mauritania in 1974 to that in 1976?
Offer a very short reply. 0.87. What is the ratio of the Grants(current US$) in Nigeria in 1974 to that in 1976?
Your response must be concise. 1.34. What is the ratio of the Grants(current US$) of Qatar in 1974 to that in 1976?
Your answer should be compact. 1.19. What is the ratio of the Grants(current US$) in Equatorial Guinea in 1974 to that in 1977?
Give a very brief answer. 1.88. What is the ratio of the Grants(current US$) of Mauritania in 1974 to that in 1977?
Provide a short and direct response. 0.77. What is the ratio of the Grants(current US$) in Nigeria in 1974 to that in 1977?
Offer a terse response. 1.28. What is the ratio of the Grants(current US$) in Qatar in 1974 to that in 1977?
Keep it short and to the point. 0.61. What is the ratio of the Grants(current US$) of Equatorial Guinea in 1974 to that in 1978?
Your answer should be very brief. 1.08. What is the ratio of the Grants(current US$) in Mauritania in 1974 to that in 1978?
Offer a terse response. 0.64. What is the ratio of the Grants(current US$) in Nigeria in 1974 to that in 1978?
Provide a succinct answer. 1.14. What is the ratio of the Grants(current US$) of Qatar in 1974 to that in 1978?
Provide a short and direct response. 3.64. What is the ratio of the Grants(current US$) in Equatorial Guinea in 1974 to that in 1979?
Provide a short and direct response. 0.29. What is the ratio of the Grants(current US$) of Mauritania in 1974 to that in 1979?
Your response must be concise. 0.42. What is the ratio of the Grants(current US$) of Nigeria in 1974 to that in 1979?
Your answer should be very brief. 0.98. What is the ratio of the Grants(current US$) of Qatar in 1974 to that in 1979?
Make the answer very short. 3. What is the ratio of the Grants(current US$) in Equatorial Guinea in 1975 to that in 1976?
Your answer should be very brief. 1.74. What is the ratio of the Grants(current US$) of Mauritania in 1975 to that in 1976?
Your response must be concise. 0.91. What is the ratio of the Grants(current US$) of Nigeria in 1975 to that in 1976?
Keep it short and to the point. 1.35. What is the ratio of the Grants(current US$) of Qatar in 1975 to that in 1976?
Your response must be concise. 1.79. What is the ratio of the Grants(current US$) of Equatorial Guinea in 1975 to that in 1977?
Offer a very short reply. 2.15. What is the ratio of the Grants(current US$) of Mauritania in 1975 to that in 1977?
Keep it short and to the point. 0.8. What is the ratio of the Grants(current US$) of Nigeria in 1975 to that in 1977?
Provide a short and direct response. 1.29. What is the ratio of the Grants(current US$) of Qatar in 1975 to that in 1977?
Keep it short and to the point. 0.92. What is the ratio of the Grants(current US$) of Equatorial Guinea in 1975 to that in 1978?
Ensure brevity in your answer.  1.24. What is the ratio of the Grants(current US$) of Mauritania in 1975 to that in 1978?
Give a very brief answer. 0.67. What is the ratio of the Grants(current US$) of Nigeria in 1975 to that in 1978?
Offer a very short reply. 1.15. What is the ratio of the Grants(current US$) in Equatorial Guinea in 1975 to that in 1979?
Ensure brevity in your answer.  0.33. What is the ratio of the Grants(current US$) in Mauritania in 1975 to that in 1979?
Give a very brief answer. 0.44. What is the ratio of the Grants(current US$) of Nigeria in 1975 to that in 1979?
Your answer should be compact. 0.99. What is the ratio of the Grants(current US$) of Qatar in 1975 to that in 1979?
Make the answer very short. 4.53. What is the ratio of the Grants(current US$) of Equatorial Guinea in 1976 to that in 1977?
Offer a very short reply. 1.24. What is the ratio of the Grants(current US$) of Mauritania in 1976 to that in 1977?
Offer a terse response. 0.88. What is the ratio of the Grants(current US$) in Nigeria in 1976 to that in 1977?
Give a very brief answer. 0.96. What is the ratio of the Grants(current US$) of Qatar in 1976 to that in 1977?
Provide a short and direct response. 0.51. What is the ratio of the Grants(current US$) of Equatorial Guinea in 1976 to that in 1978?
Your answer should be compact. 0.71. What is the ratio of the Grants(current US$) in Mauritania in 1976 to that in 1978?
Your answer should be compact. 0.74. What is the ratio of the Grants(current US$) of Nigeria in 1976 to that in 1978?
Make the answer very short. 0.85. What is the ratio of the Grants(current US$) in Qatar in 1976 to that in 1978?
Make the answer very short. 3.07. What is the ratio of the Grants(current US$) of Equatorial Guinea in 1976 to that in 1979?
Ensure brevity in your answer.  0.19. What is the ratio of the Grants(current US$) of Mauritania in 1976 to that in 1979?
Offer a terse response. 0.48. What is the ratio of the Grants(current US$) in Nigeria in 1976 to that in 1979?
Make the answer very short. 0.73. What is the ratio of the Grants(current US$) in Qatar in 1976 to that in 1979?
Give a very brief answer. 2.53. What is the ratio of the Grants(current US$) of Equatorial Guinea in 1977 to that in 1978?
Provide a succinct answer. 0.58. What is the ratio of the Grants(current US$) in Mauritania in 1977 to that in 1978?
Offer a terse response. 0.84. What is the ratio of the Grants(current US$) in Nigeria in 1977 to that in 1978?
Your response must be concise. 0.89. What is the ratio of the Grants(current US$) of Equatorial Guinea in 1977 to that in 1979?
Your answer should be very brief. 0.15. What is the ratio of the Grants(current US$) of Mauritania in 1977 to that in 1979?
Give a very brief answer. 0.55. What is the ratio of the Grants(current US$) in Nigeria in 1977 to that in 1979?
Your answer should be very brief. 0.76. What is the ratio of the Grants(current US$) in Qatar in 1977 to that in 1979?
Ensure brevity in your answer.  4.94. What is the ratio of the Grants(current US$) in Equatorial Guinea in 1978 to that in 1979?
Provide a succinct answer. 0.27. What is the ratio of the Grants(current US$) in Mauritania in 1978 to that in 1979?
Your response must be concise. 0.65. What is the ratio of the Grants(current US$) in Nigeria in 1978 to that in 1979?
Give a very brief answer. 0.86. What is the ratio of the Grants(current US$) in Qatar in 1978 to that in 1979?
Provide a succinct answer. 0.82. What is the difference between the highest and the second highest Grants(current US$) of Equatorial Guinea?
Keep it short and to the point. 1.19e+06. What is the difference between the highest and the second highest Grants(current US$) of Mauritania?
Keep it short and to the point. 8.14e+06. What is the difference between the highest and the second highest Grants(current US$) in Nigeria?
Keep it short and to the point. 3.18e+06. What is the difference between the highest and the lowest Grants(current US$) of Equatorial Guinea?
Provide a short and direct response. 1.86e+06. What is the difference between the highest and the lowest Grants(current US$) in Mauritania?
Your response must be concise. 1.56e+07. What is the difference between the highest and the lowest Grants(current US$) of Nigeria?
Offer a terse response. 1.41e+07. 